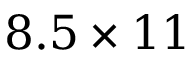Convert formula to latex. <formula><loc_0><loc_0><loc_500><loc_500>8 . 5 \times 1 1</formula> 